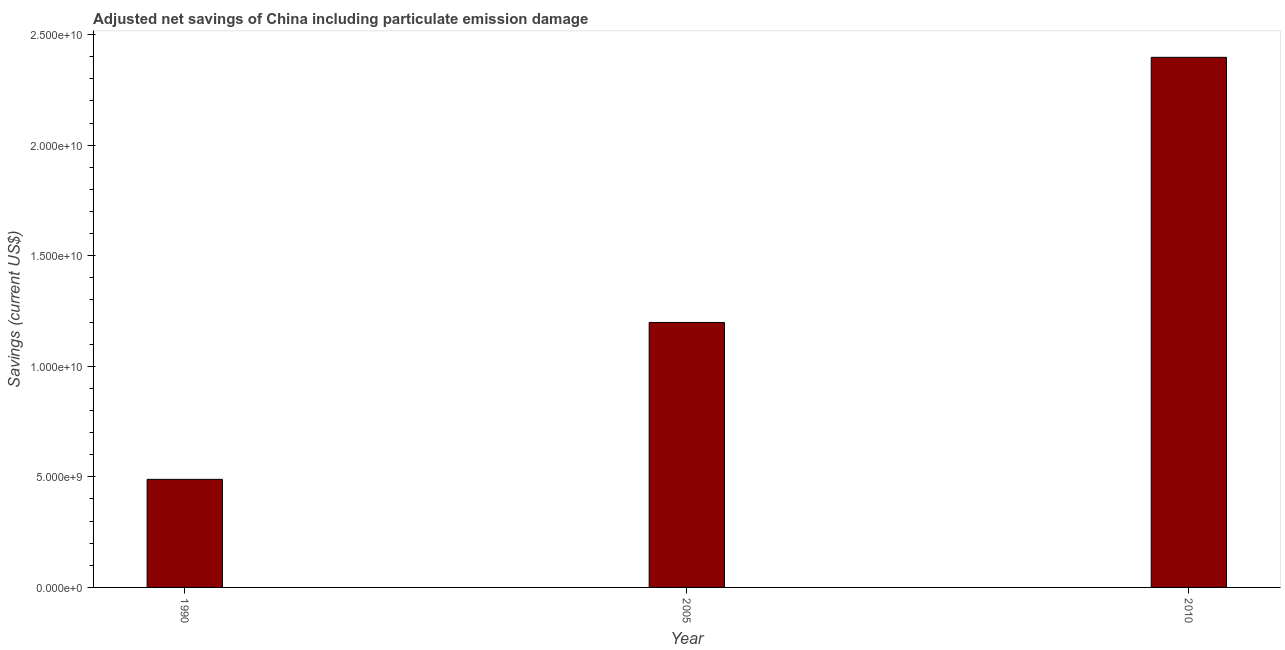Does the graph contain grids?
Provide a succinct answer. No. What is the title of the graph?
Your answer should be very brief. Adjusted net savings of China including particulate emission damage. What is the label or title of the X-axis?
Make the answer very short. Year. What is the label or title of the Y-axis?
Keep it short and to the point. Savings (current US$). What is the adjusted net savings in 2010?
Give a very brief answer. 2.40e+1. Across all years, what is the maximum adjusted net savings?
Provide a succinct answer. 2.40e+1. Across all years, what is the minimum adjusted net savings?
Keep it short and to the point. 4.89e+09. In which year was the adjusted net savings maximum?
Offer a very short reply. 2010. In which year was the adjusted net savings minimum?
Ensure brevity in your answer.  1990. What is the sum of the adjusted net savings?
Offer a terse response. 4.08e+1. What is the difference between the adjusted net savings in 2005 and 2010?
Give a very brief answer. -1.20e+1. What is the average adjusted net savings per year?
Provide a short and direct response. 1.36e+1. What is the median adjusted net savings?
Ensure brevity in your answer.  1.20e+1. In how many years, is the adjusted net savings greater than 8000000000 US$?
Keep it short and to the point. 2. What is the ratio of the adjusted net savings in 2005 to that in 2010?
Ensure brevity in your answer.  0.5. Is the adjusted net savings in 2005 less than that in 2010?
Your answer should be compact. Yes. What is the difference between the highest and the second highest adjusted net savings?
Your answer should be compact. 1.20e+1. Is the sum of the adjusted net savings in 1990 and 2010 greater than the maximum adjusted net savings across all years?
Provide a succinct answer. Yes. What is the difference between the highest and the lowest adjusted net savings?
Make the answer very short. 1.91e+1. How many bars are there?
Provide a succinct answer. 3. Are all the bars in the graph horizontal?
Offer a terse response. No. What is the difference between two consecutive major ticks on the Y-axis?
Ensure brevity in your answer.  5.00e+09. Are the values on the major ticks of Y-axis written in scientific E-notation?
Offer a terse response. Yes. What is the Savings (current US$) of 1990?
Your response must be concise. 4.89e+09. What is the Savings (current US$) of 2005?
Offer a very short reply. 1.20e+1. What is the Savings (current US$) in 2010?
Offer a very short reply. 2.40e+1. What is the difference between the Savings (current US$) in 1990 and 2005?
Offer a terse response. -7.09e+09. What is the difference between the Savings (current US$) in 1990 and 2010?
Your response must be concise. -1.91e+1. What is the difference between the Savings (current US$) in 2005 and 2010?
Make the answer very short. -1.20e+1. What is the ratio of the Savings (current US$) in 1990 to that in 2005?
Your answer should be very brief. 0.41. What is the ratio of the Savings (current US$) in 1990 to that in 2010?
Offer a terse response. 0.2. What is the ratio of the Savings (current US$) in 2005 to that in 2010?
Give a very brief answer. 0.5. 